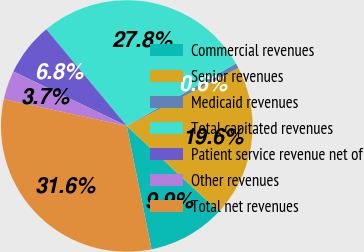<chart> <loc_0><loc_0><loc_500><loc_500><pie_chart><fcel>Commercial revenues<fcel>Senior revenues<fcel>Medicaid revenues<fcel>Total capitated revenues<fcel>Patient service revenue net of<fcel>Other revenues<fcel>Total net revenues<nl><fcel>9.91%<fcel>19.57%<fcel>0.63%<fcel>27.78%<fcel>6.82%<fcel>3.72%<fcel>31.57%<nl></chart> 